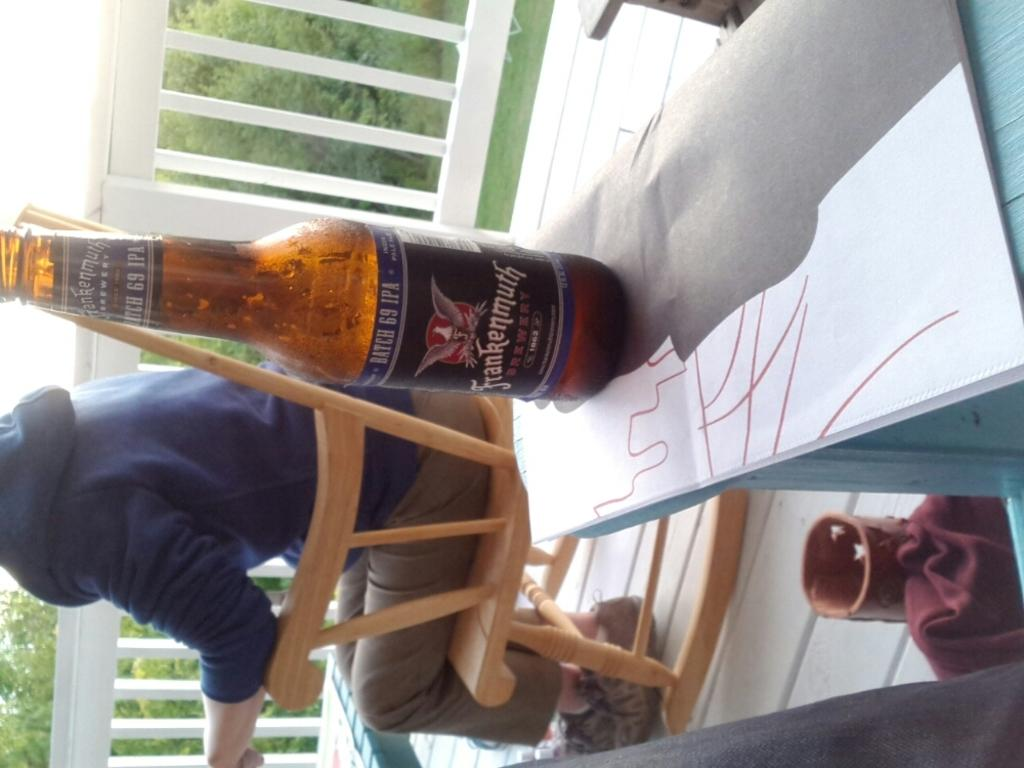<image>
Present a compact description of the photo's key features. A person sits on a wooden rocking chair next to a table that has a bottle from Frankenmuth brewery on it. 